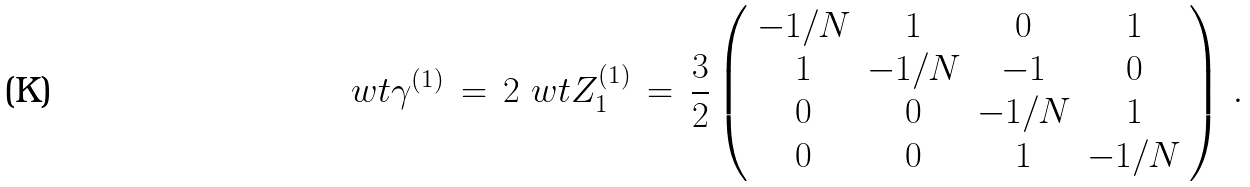<formula> <loc_0><loc_0><loc_500><loc_500>\ w t \gamma ^ { ( 1 ) } \, = \, 2 \ w t Z _ { 1 } ^ { ( 1 ) } \, = \, \frac { 3 } { 2 } \left ( \begin{array} { c c c c } - 1 / N & 1 & 0 & 1 \\ 1 & - 1 / N & - 1 & 0 \\ 0 & 0 & - 1 / N & 1 \\ 0 & 0 & 1 & - 1 / N \end{array} \right ) \, .</formula> 